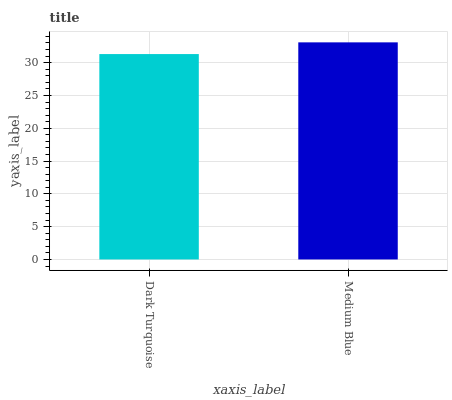Is Dark Turquoise the minimum?
Answer yes or no. Yes. Is Medium Blue the maximum?
Answer yes or no. Yes. Is Medium Blue the minimum?
Answer yes or no. No. Is Medium Blue greater than Dark Turquoise?
Answer yes or no. Yes. Is Dark Turquoise less than Medium Blue?
Answer yes or no. Yes. Is Dark Turquoise greater than Medium Blue?
Answer yes or no. No. Is Medium Blue less than Dark Turquoise?
Answer yes or no. No. Is Medium Blue the high median?
Answer yes or no. Yes. Is Dark Turquoise the low median?
Answer yes or no. Yes. Is Dark Turquoise the high median?
Answer yes or no. No. Is Medium Blue the low median?
Answer yes or no. No. 